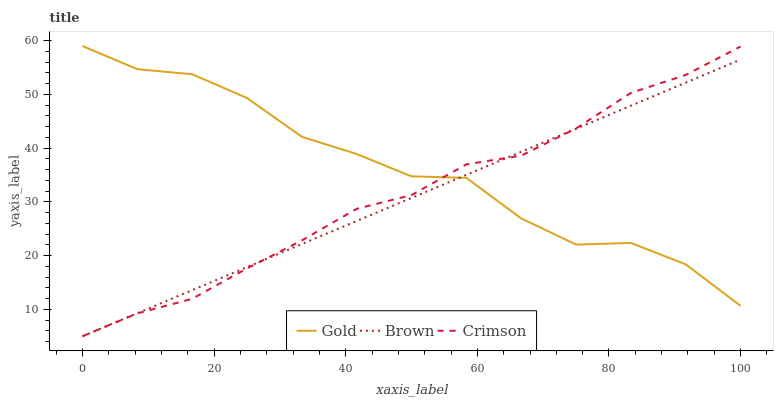Does Brown have the minimum area under the curve?
Answer yes or no. Yes. Does Gold have the maximum area under the curve?
Answer yes or no. Yes. Does Gold have the minimum area under the curve?
Answer yes or no. No. Does Brown have the maximum area under the curve?
Answer yes or no. No. Is Brown the smoothest?
Answer yes or no. Yes. Is Gold the roughest?
Answer yes or no. Yes. Is Gold the smoothest?
Answer yes or no. No. Is Brown the roughest?
Answer yes or no. No. Does Crimson have the lowest value?
Answer yes or no. Yes. Does Gold have the lowest value?
Answer yes or no. No. Does Gold have the highest value?
Answer yes or no. Yes. Does Brown have the highest value?
Answer yes or no. No. Does Brown intersect Gold?
Answer yes or no. Yes. Is Brown less than Gold?
Answer yes or no. No. Is Brown greater than Gold?
Answer yes or no. No. 